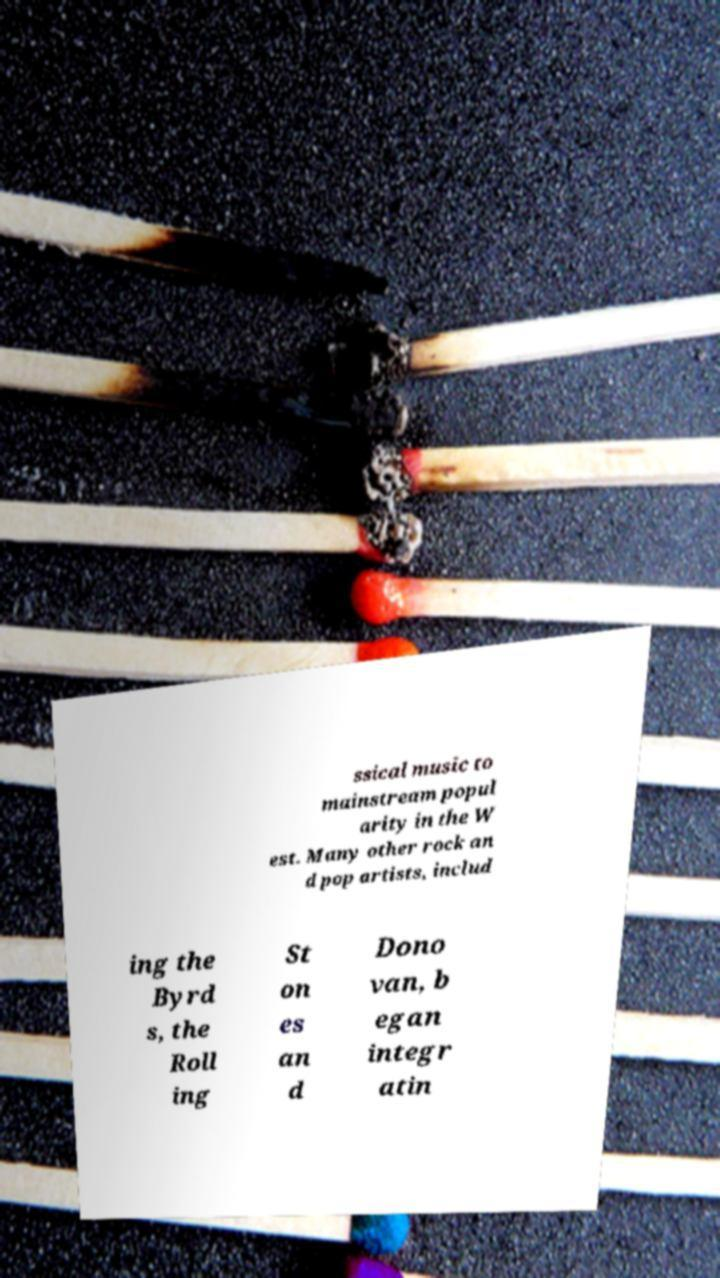Can you read and provide the text displayed in the image?This photo seems to have some interesting text. Can you extract and type it out for me? ssical music to mainstream popul arity in the W est. Many other rock an d pop artists, includ ing the Byrd s, the Roll ing St on es an d Dono van, b egan integr atin 